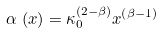Convert formula to latex. <formula><loc_0><loc_0><loc_500><loc_500>\alpha \, \left ( x \right ) = \kappa _ { 0 } ^ { \left ( 2 - \beta \right ) } x ^ { \left ( \beta - 1 \right ) }</formula> 